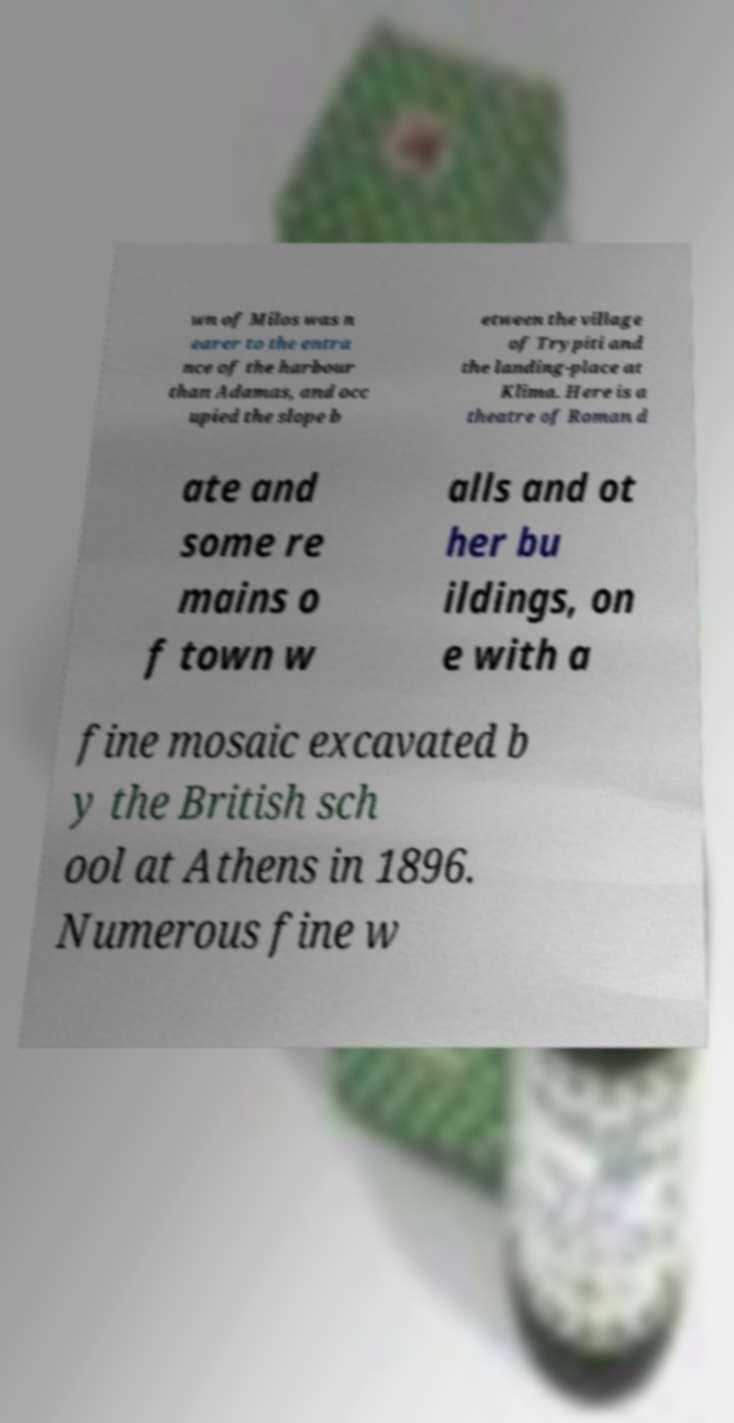I need the written content from this picture converted into text. Can you do that? wn of Milos was n earer to the entra nce of the harbour than Adamas, and occ upied the slope b etween the village of Trypiti and the landing-place at Klima. Here is a theatre of Roman d ate and some re mains o f town w alls and ot her bu ildings, on e with a fine mosaic excavated b y the British sch ool at Athens in 1896. Numerous fine w 